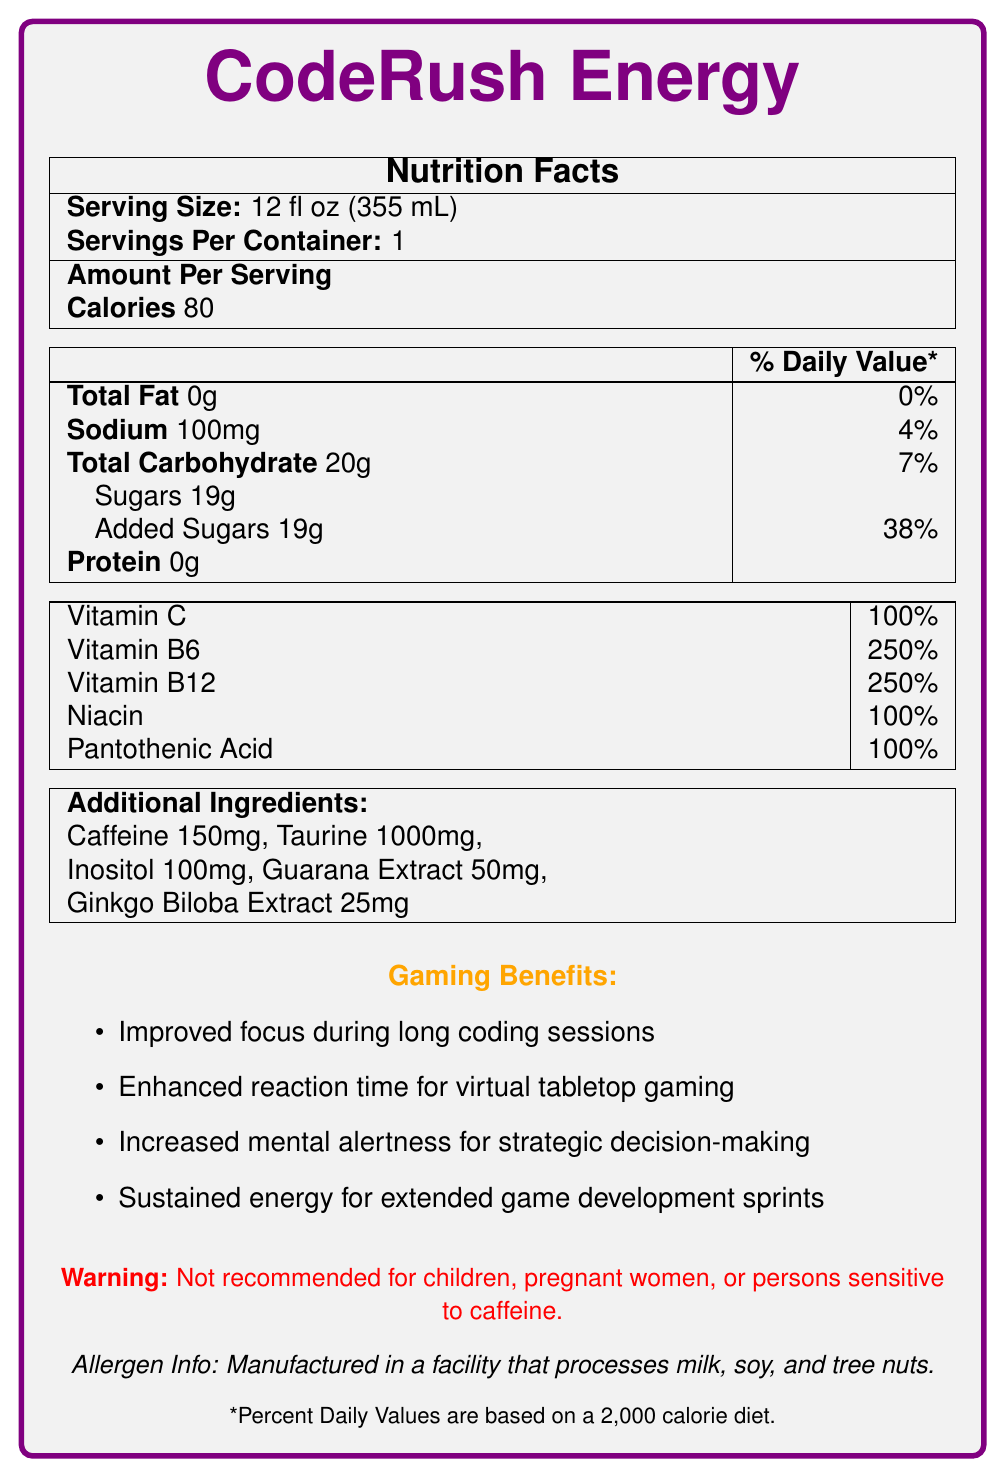What is the serving size for CodeRush Energy? The serving size is stated as "Serving Size: 12 fl oz (355 mL)" in the nutrition facts section of the document.
Answer: 12 fl oz (355 mL) How many calories are there per serving of CodeRush Energy? The calories per serving are listed as "Calories 80" in the nutrition facts section.
Answer: 80 What percentage of the daily value of Vitamin C does one serving of CodeRush Energy provide? The percentage of daily value for Vitamin C is listed as 100% in the vitamin section of the document.
Answer: 100% How much caffeine is in one serving of CodeRush Energy? The document states "Caffeine 150mg" under the additional ingredients section.
Answer: 150mg What is the amount of sodium per serving, and what percentage of the daily value does it represent? Sodium content is listed as "Sodium 100mg" and the percentage of daily value as "4%" in the nutrition facts.
Answer: 100mg, 4% Which of the following vitamins are present in CodeRush Energy? A. Vitamin D, Vitamin E, Vitamin K B. Vitamin A, Vitamin D, Vitamin E C. Vitamin C, Vitamin B6, Vitamin B12, Niacin, Pantothenic Acid D. Vitamin A, Vitamin K, Calcium The document mentions Vitamins C, B6, B12, Niacin, and Pantothenic Acid with their respective daily values.
Answer: C What is the amount of added sugars in CodeRush Energy, and what percentage of the daily value does it comprise? The added sugars amount is stated as "Added Sugars 19g" and "38%" daily value in the nutrition facts.
Answer: 19g, 38% Based on the allergen info, should someone with a tree nut allergy be cautious about consuming CodeRush Energy? The allergen information states it is manufactured in a facility that processes tree nuts.
Answer: Yes Is CodeRush Energy recommended for pregnant women? The warning clearly states that it is "Not recommended for children, pregnant women, or persons sensitive to caffeine."
Answer: No How does CodeRush Energy help gamers according to the document? The gaming benefits listed are "Improved focus during long coding sessions", "Enhanced reaction time for virtual tabletop gaming", "Increased mental alertness for strategic decision-making", and "Sustained energy for extended game development sprints".
Answer: Improved focus, enhanced reaction time, increased mental alertness, sustained energy What is the brand story behind CodeRush Energy? The brand story mentions it was developed by gamers for gamers to balance energy and focus for intense coding sessions and gaming adventures.
Answer: Developed by gamers, for gamers to provide the perfect balance of energy and focus for coding and gaming Can we determine the price of CodeRush Energy from the document? The document does not provide any information regarding the price of CodeRush Energy.
Answer: Cannot be determined 